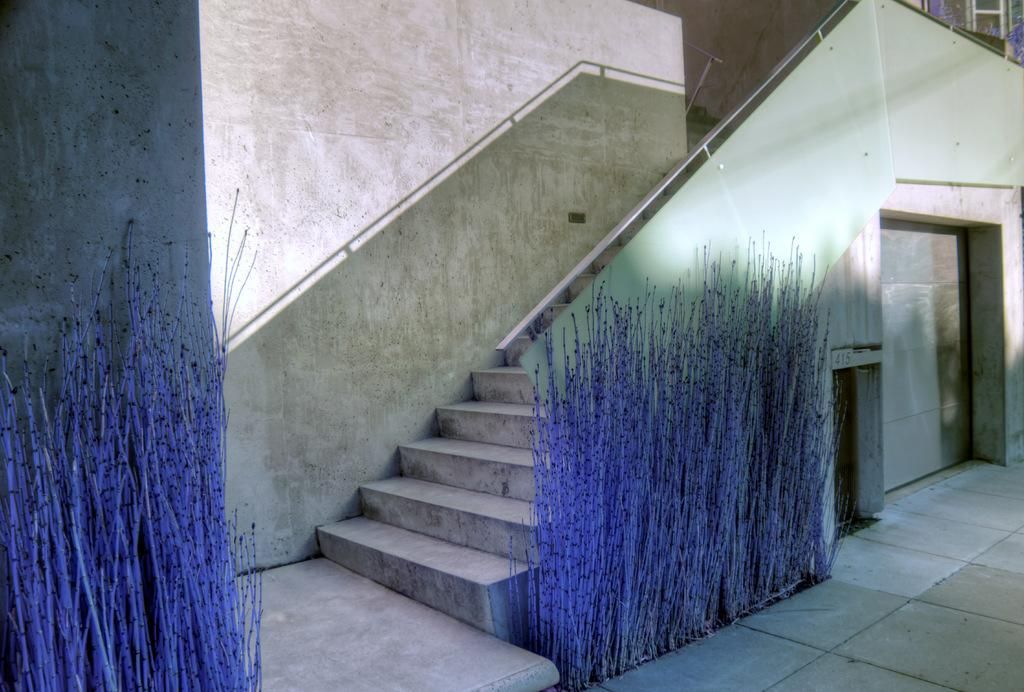What type of architectural feature is present in the image? There are stairs in the image. What color is the wall in the background? The wall in the background is white. Can you describe any objects in the image based on their color? Yes, there are objects in blue color in the image. What type of creature is the governor of the nation in the image? There is no creature, governor, or nation present in the image. 